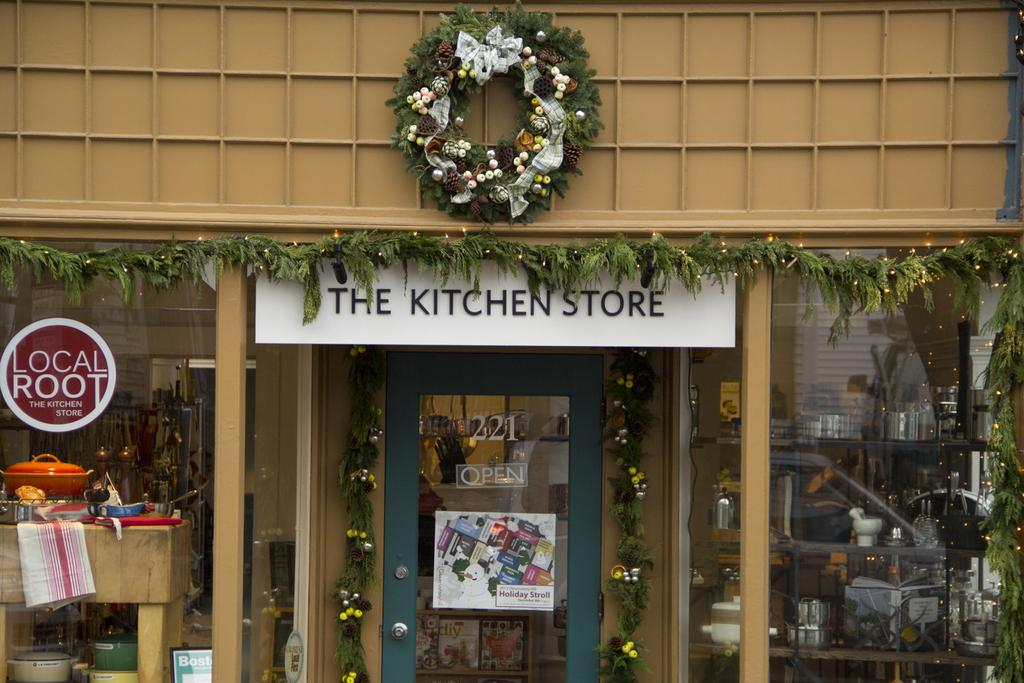<image>
Provide a brief description of the given image. A store front called the kitchen store is covered in wreaths and other Christmas decorations. 